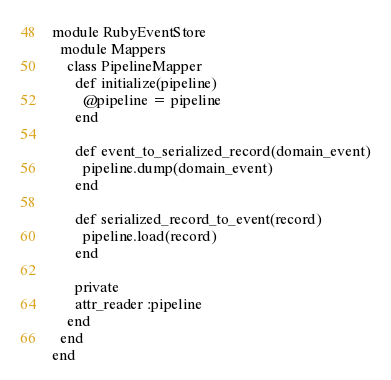Convert code to text. <code><loc_0><loc_0><loc_500><loc_500><_Ruby_>module RubyEventStore
  module Mappers
    class PipelineMapper
      def initialize(pipeline)
        @pipeline = pipeline
      end

      def event_to_serialized_record(domain_event)
        pipeline.dump(domain_event)
      end

      def serialized_record_to_event(record)
        pipeline.load(record)
      end

      private
      attr_reader :pipeline
    end
  end
end
</code> 